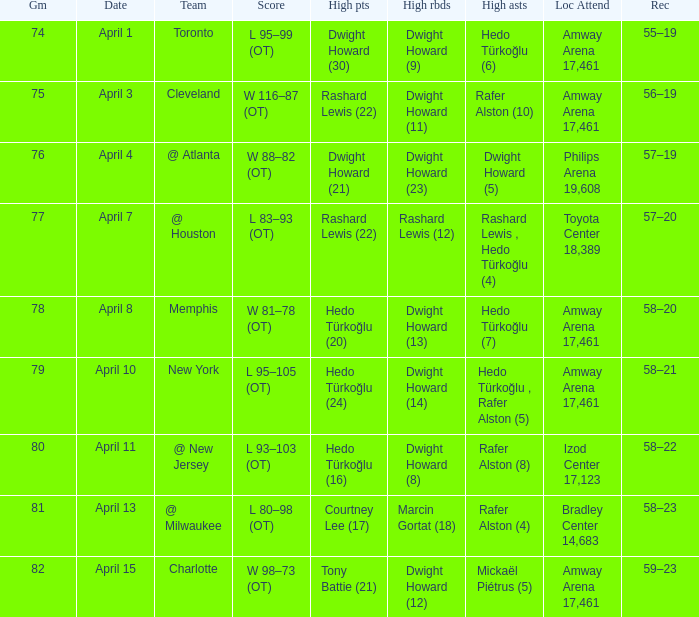What is the highest rebounds for game 81? Marcin Gortat (18). 